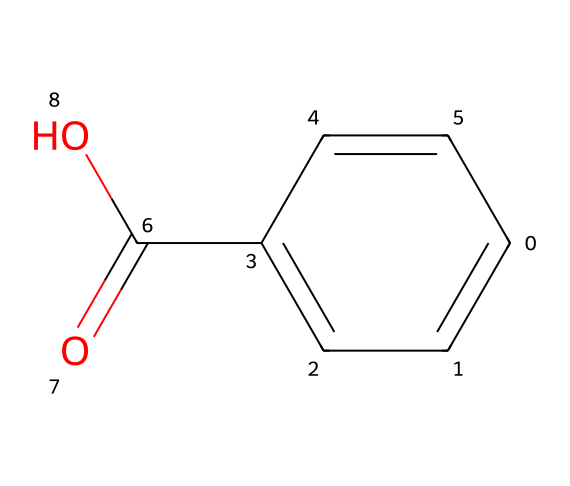What is the molecular formula of this chemical? To find the molecular formula, count the number of each type of atom in the SMILES representation. The structure corresponds to C7H6O2, because there are 7 carbon (C) atoms, 6 hydrogen (H) atoms, and 2 oxygen (O) atoms.
Answer: C7H6O2 How many carbon atoms are in this molecule? The SMILES notation shows 7 carbon atoms, which can be counted from the structure by identifying each 'C' in the formula.
Answer: 7 What type of functional group is present in this chemical? The presence of the carboxylic acid group (-COOH) indicates a functional group. This can be seen in the structure where there is a carbon atom connected to a carbonyl (C=O) and a hydroxyl (-OH) group.
Answer: carboxylic acid Does this molecule have any double bonds? To determine double bonds, look for the '=' symbol in the SMILES notation. The structure has one C=C double bond and one C=O double bond, confirming the presence of double bonds.
Answer: Yes What is the role of benzoic acid as a preservative? As a preservative, benzoic acid inhibits the growth of mold, yeast, and some bacteria, thereby prolonging the shelf life of food products, including cranberries. Its effectiveness can be attributed to its low pH and acid nature.
Answer: Inhibits microbial growth Is benzoic acid naturally occurring? Yes, benzoic acid is a natural compound found in various fruits, including cranberries. It can also be derived from the fermentation of plants, linking its presence to ancient medicinal uses mentioned in religious texts.
Answer: Yes 